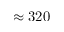<formula> <loc_0><loc_0><loc_500><loc_500>\approx 3 2 0</formula> 